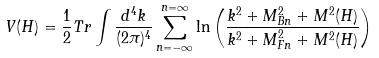Convert formula to latex. <formula><loc_0><loc_0><loc_500><loc_500>V ( H ) = \frac { 1 } { 2 } T r \int \frac { d ^ { 4 } k } { ( 2 \pi ) ^ { 4 } } \sum _ { n = - \infty } ^ { n = \infty } \ln \left ( \frac { k ^ { 2 } + M ^ { 2 } _ { B n } + M ^ { 2 } ( H ) } { k ^ { 2 } + M ^ { 2 } _ { F n } + M ^ { 2 } ( H ) } \right )</formula> 